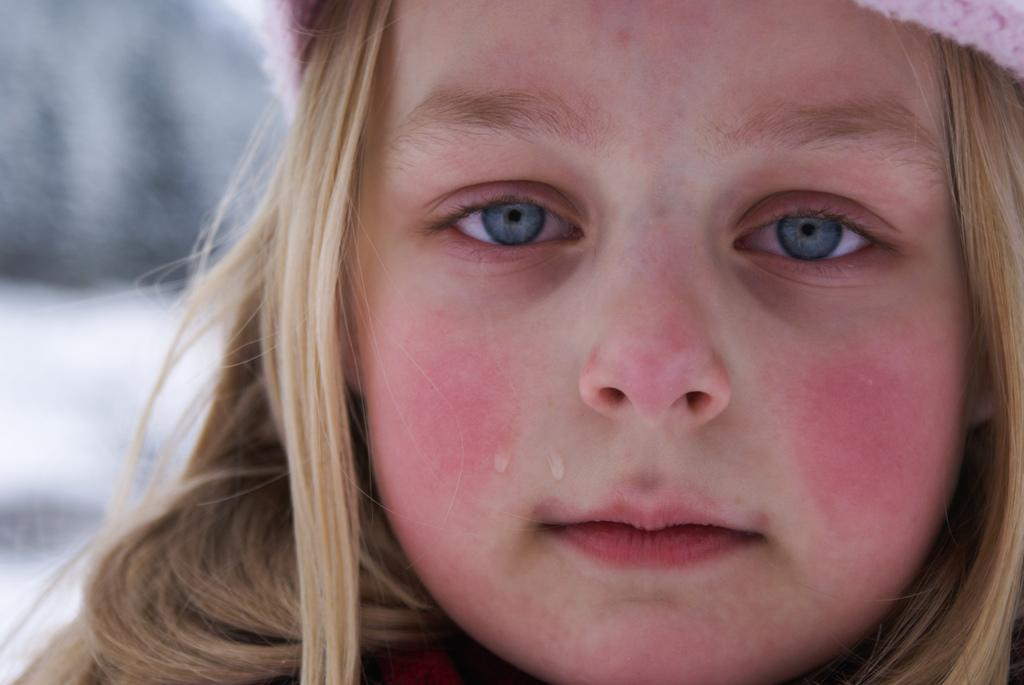Who is the main subject in the image? There is a girl in the image. What is the girl doing in the image? The girl is crying. Can you describe the background of the image? The background of the image is blurred. What type of hair accessory is the girl wearing in the image? There is no information about the girl's hair or any hair accessory in the image. What fictional character does the girl resemble in the image? The image does not depict any fictional characters, only a girl who is crying. 